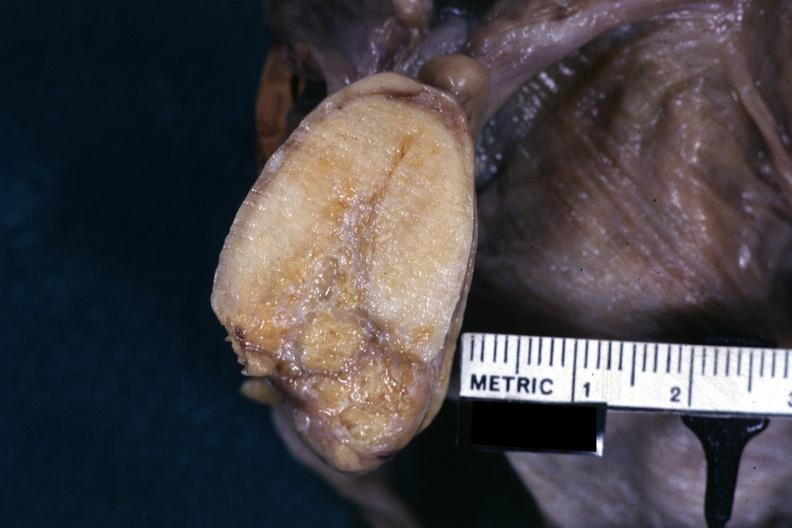what is present?
Answer the question using a single word or phrase. Female reproductive 